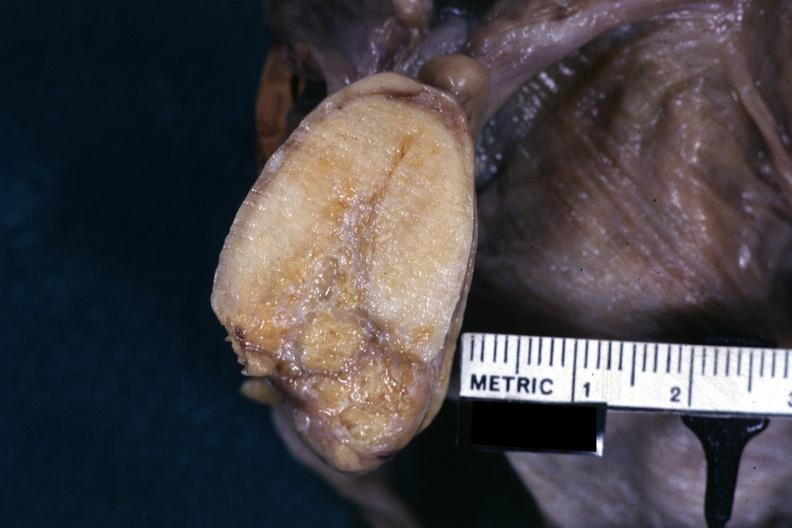what is present?
Answer the question using a single word or phrase. Female reproductive 